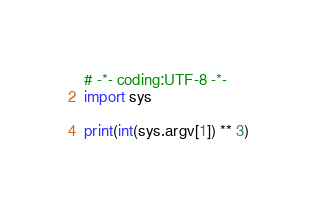Convert code to text. <code><loc_0><loc_0><loc_500><loc_500><_Python_># -*- coding:UTF-8 -*-
import sys

print(int(sys.argv[1]) ** 3)</code> 